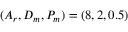<formula> <loc_0><loc_0><loc_500><loc_500>( A _ { r } , D _ { m } , P _ { m } ) = ( 8 , 2 , 0 . 5 )</formula> 